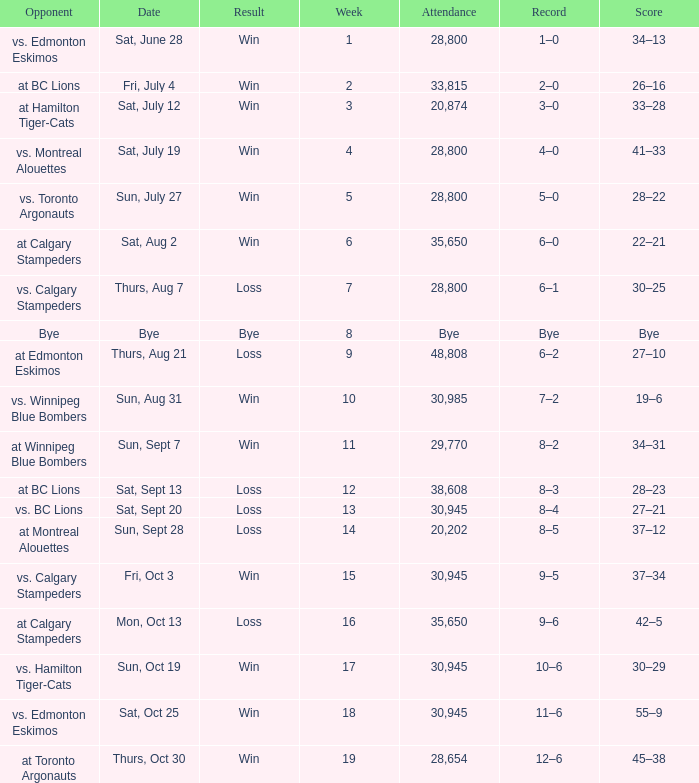What was the date of the game with an attendance of 20,874 fans? Sat, July 12. 